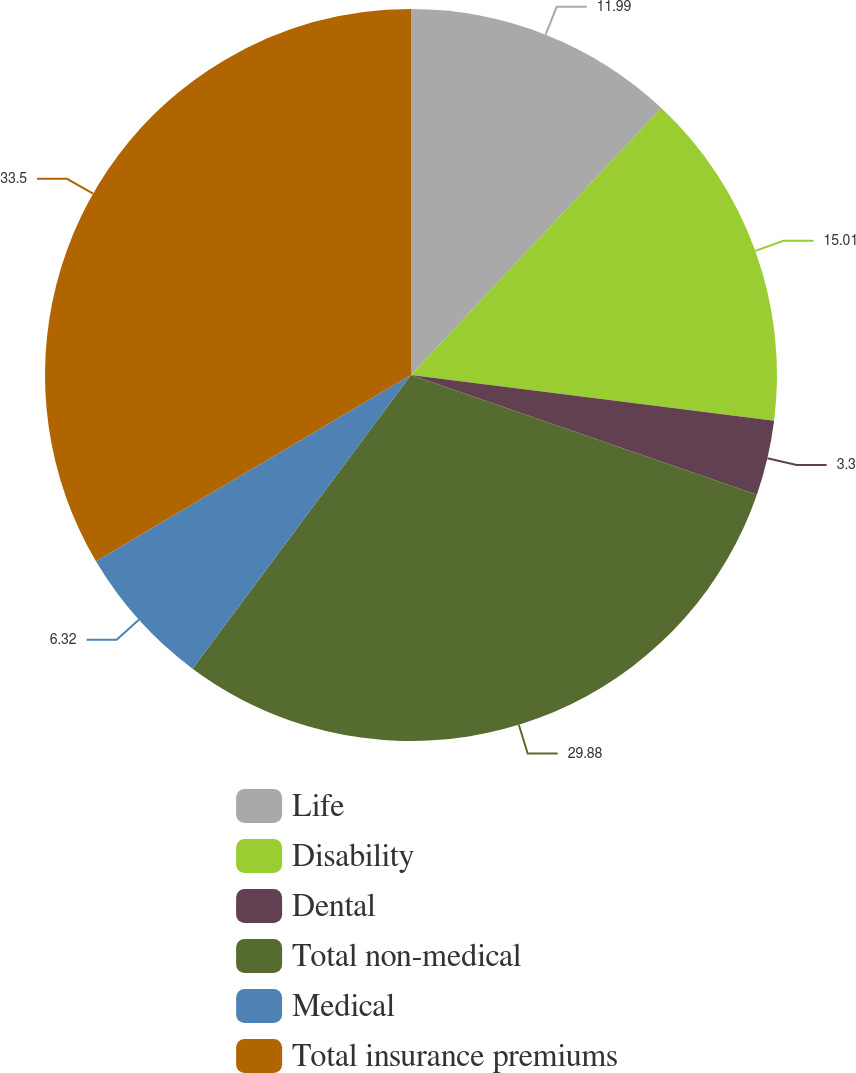<chart> <loc_0><loc_0><loc_500><loc_500><pie_chart><fcel>Life<fcel>Disability<fcel>Dental<fcel>Total non-medical<fcel>Medical<fcel>Total insurance premiums<nl><fcel>11.99%<fcel>15.01%<fcel>3.3%<fcel>29.88%<fcel>6.32%<fcel>33.5%<nl></chart> 